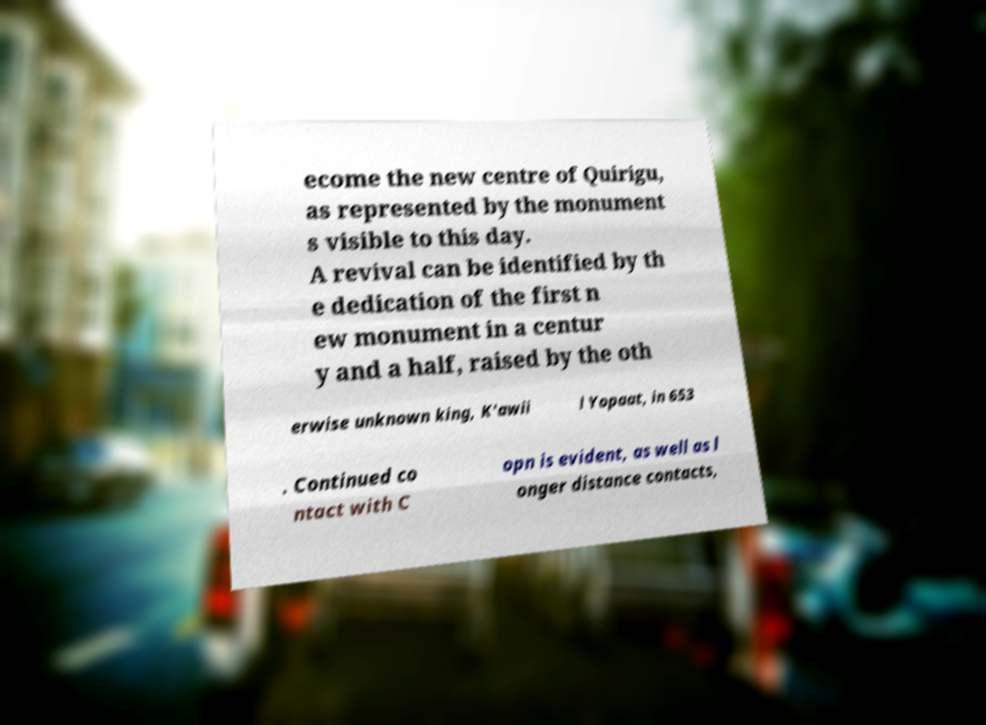There's text embedded in this image that I need extracted. Can you transcribe it verbatim? ecome the new centre of Quirigu, as represented by the monument s visible to this day. A revival can be identified by th e dedication of the first n ew monument in a centur y and a half, raised by the oth erwise unknown king, K'awii l Yopaat, in 653 . Continued co ntact with C opn is evident, as well as l onger distance contacts, 